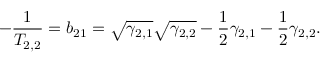Convert formula to latex. <formula><loc_0><loc_0><loc_500><loc_500>- \frac { 1 } { T _ { 2 , 2 } } = b _ { 2 1 } = \sqrt { \gamma _ { 2 , 1 } } \sqrt { \gamma _ { 2 , 2 } } - \frac { 1 } { 2 } \gamma _ { 2 , 1 } - \frac { 1 } { 2 } \gamma _ { 2 , 2 } .</formula> 